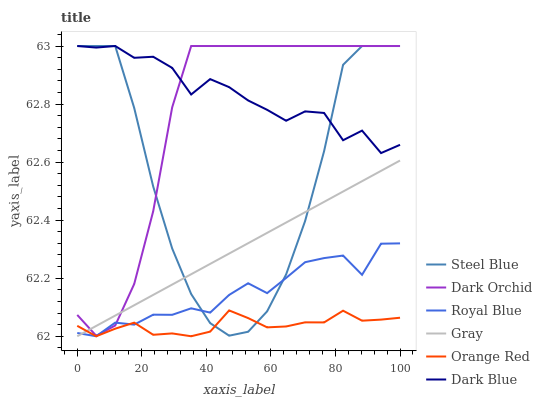Does Orange Red have the minimum area under the curve?
Answer yes or no. Yes. Does Dark Blue have the maximum area under the curve?
Answer yes or no. Yes. Does Royal Blue have the minimum area under the curve?
Answer yes or no. No. Does Royal Blue have the maximum area under the curve?
Answer yes or no. No. Is Gray the smoothest?
Answer yes or no. Yes. Is Steel Blue the roughest?
Answer yes or no. Yes. Is Royal Blue the smoothest?
Answer yes or no. No. Is Royal Blue the roughest?
Answer yes or no. No. Does Steel Blue have the lowest value?
Answer yes or no. No. Does Dark Blue have the highest value?
Answer yes or no. Yes. Does Royal Blue have the highest value?
Answer yes or no. No. Is Royal Blue less than Dark Blue?
Answer yes or no. Yes. Is Dark Blue greater than Orange Red?
Answer yes or no. Yes. Does Dark Orchid intersect Royal Blue?
Answer yes or no. Yes. Is Dark Orchid less than Royal Blue?
Answer yes or no. No. Is Dark Orchid greater than Royal Blue?
Answer yes or no. No. Does Royal Blue intersect Dark Blue?
Answer yes or no. No. 